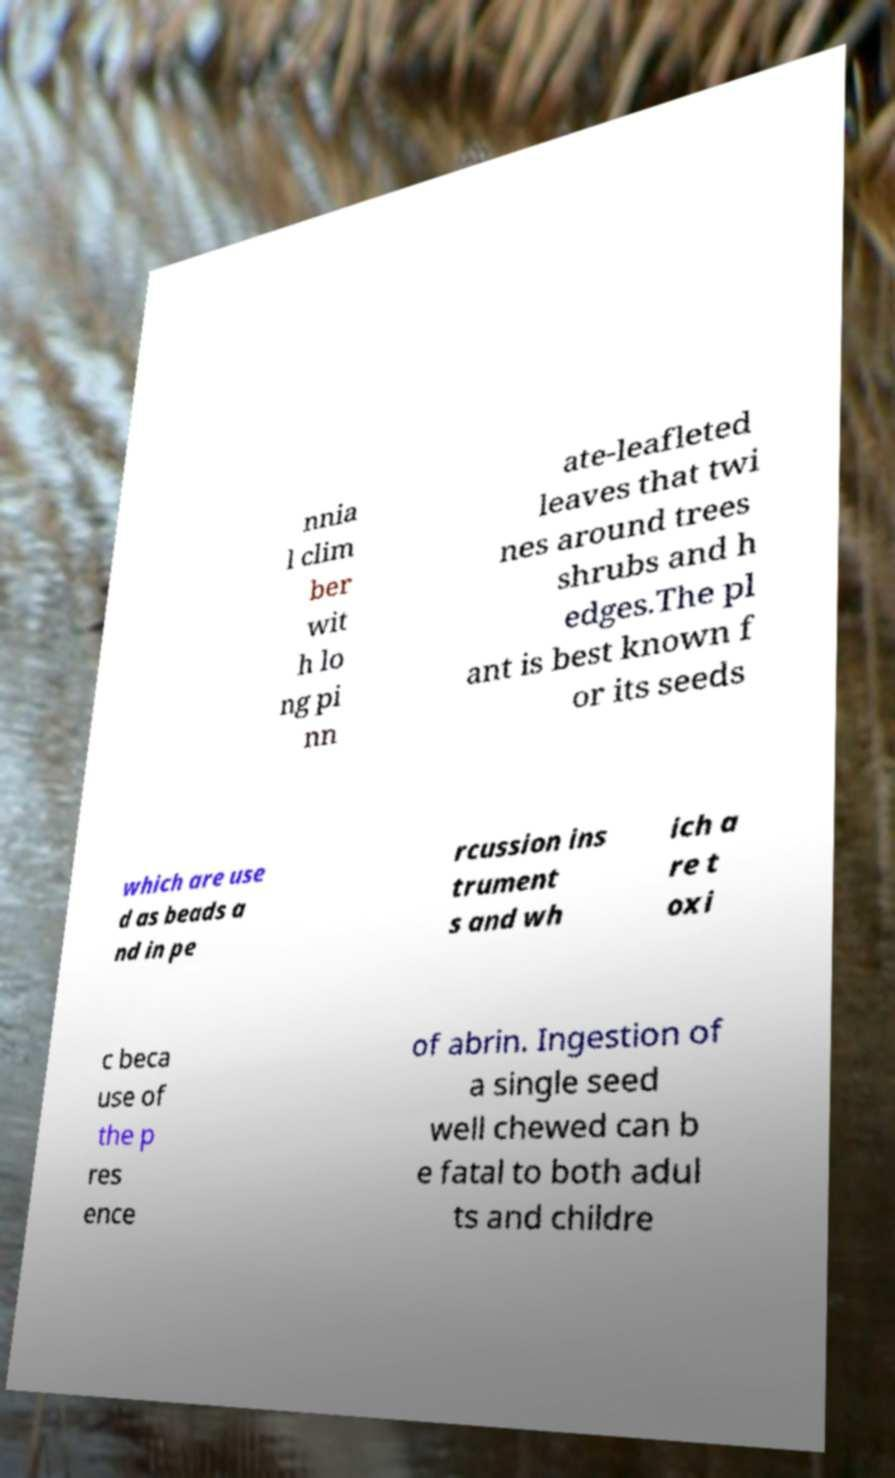Can you accurately transcribe the text from the provided image for me? nnia l clim ber wit h lo ng pi nn ate-leafleted leaves that twi nes around trees shrubs and h edges.The pl ant is best known f or its seeds which are use d as beads a nd in pe rcussion ins trument s and wh ich a re t oxi c beca use of the p res ence of abrin. Ingestion of a single seed well chewed can b e fatal to both adul ts and childre 